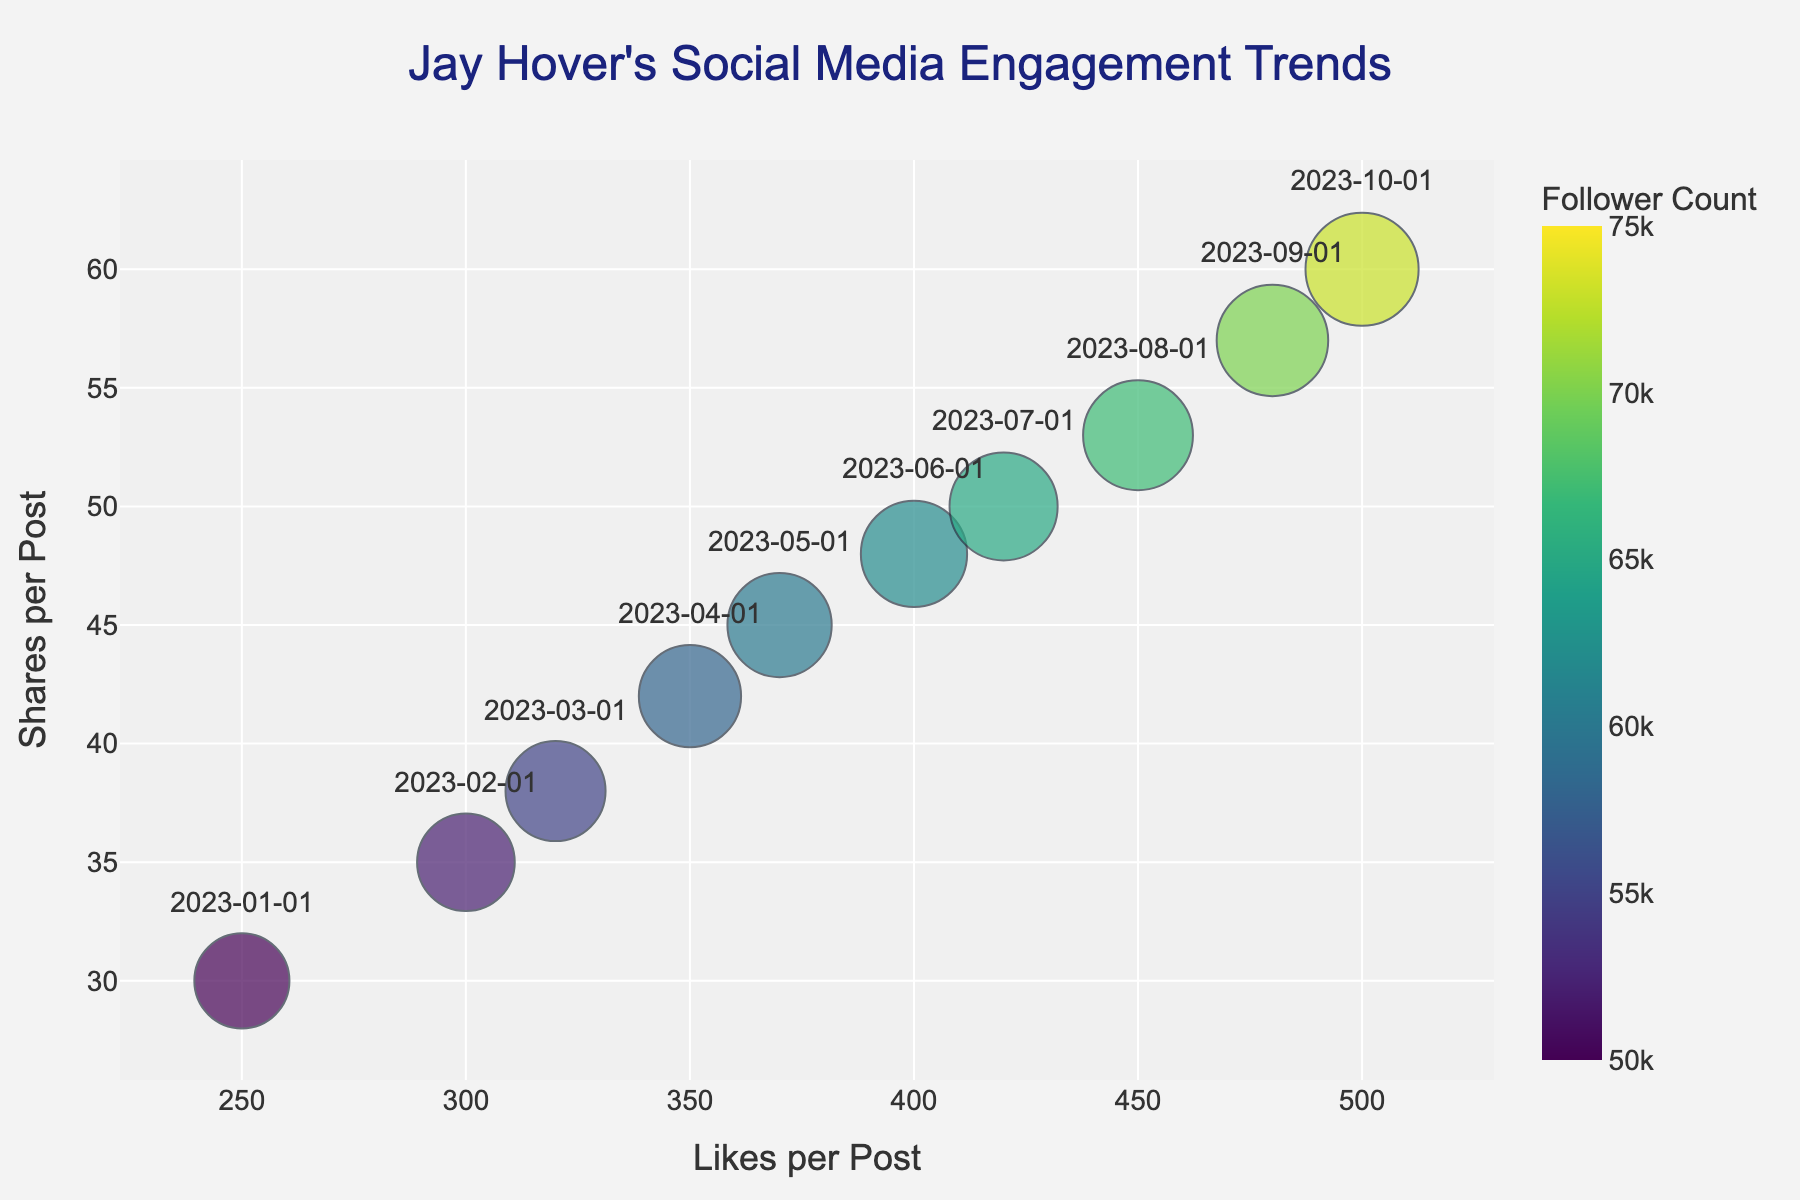How many data points are shown in the bubble chart? Looking at the chart, each date represents one data point, ranging from January to October. Counting the months, there are ten data points.
Answer: 10 What are the axis labels for the bubble chart? The x-axis label is "Likes per Post," and the y-axis label is "Shares per Post."
Answer: Likes per Post, Shares per Post Which month had the highest number of shares? The y-axis represents shares, and by finding the highest point on the y-axis, we see that October has the highest number of shares.
Answer: October What is the average number of comments per month? To find the average, we sum the number of comments for each month and then divide by the total number of months. The sum is 675, and there are 10 months, so 675 / 10 = 67.5.
Answer: 67.5 How did the number of likes change from January to October? The x-axis represents the number of likes. In January, the value is 250, and in October, it is 500. So, the likes increased from 250 to 500.
Answer: Increased by 250 Which month showed the largest growth in follower count? Comparing follower counts month by month, the largest increase occurred from September to October (70000 to 73000), a growth of 3000 followers.
Answer: October Between July and August, which month had more shares per post? By comparing the y-axis values, August has a higher number of shares per post (53) compared to July (50).
Answer: August Does an increase in followers generally correlate with an increase in likes? Observing the trend, as the follower count increases from January to October, the number of likes also increases, indicating a positive correlation.
Answer: Yes For which month is the bubble size the smallest, and what can you infer from it? Bubble size is based on the number of comments. The smallest bubble appears in January, with the smallest number of comments (45).
Answer: January, fewer comments Which month had the highest number of likes, and how did it affect the number of shares and comments? In October, the highest number of likes (500) coincides with the highest levels of shares (60) and comments (90), indicating a substantial engagement.
Answer: October, high shares and comments 